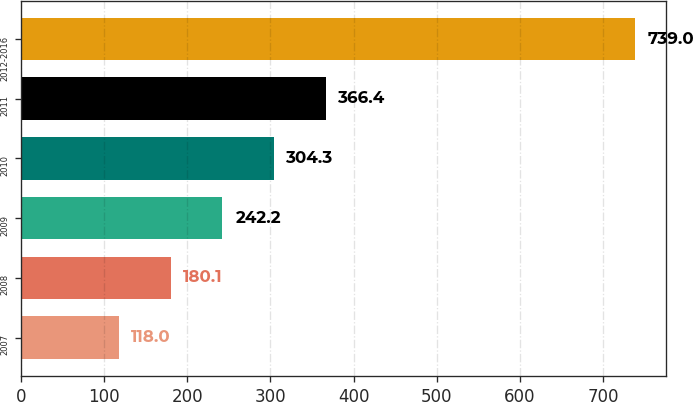Convert chart to OTSL. <chart><loc_0><loc_0><loc_500><loc_500><bar_chart><fcel>2007<fcel>2008<fcel>2009<fcel>2010<fcel>2011<fcel>2012-2016<nl><fcel>118<fcel>180.1<fcel>242.2<fcel>304.3<fcel>366.4<fcel>739<nl></chart> 